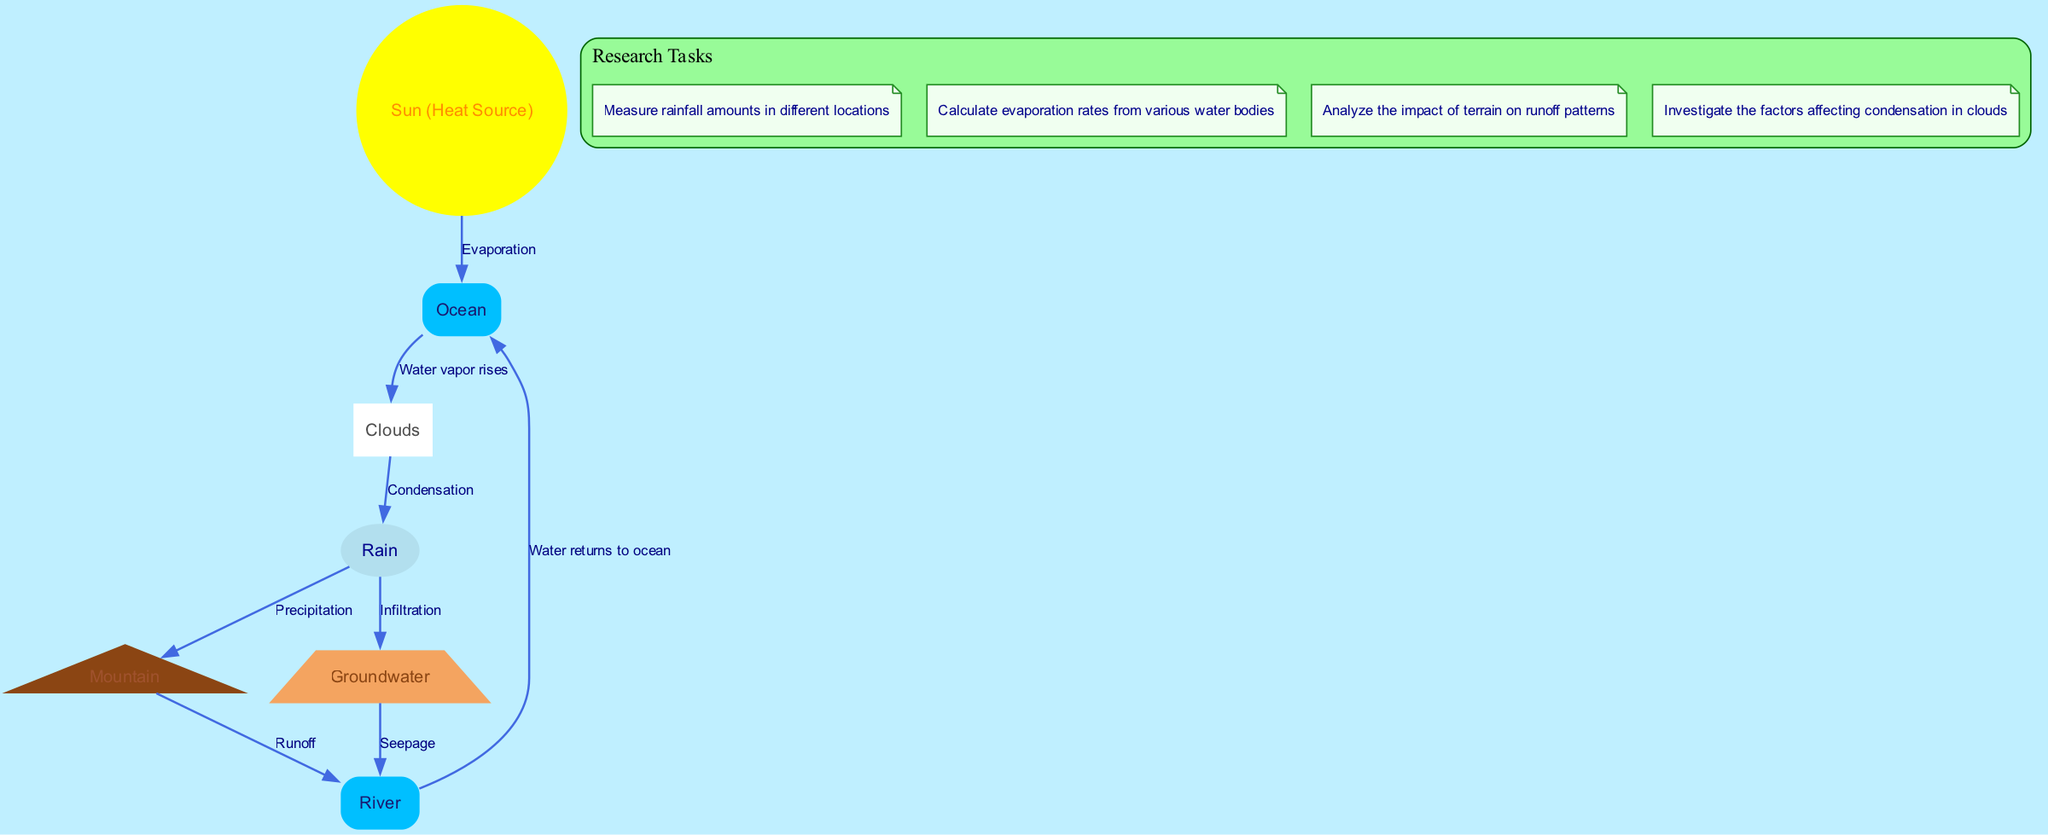What are the key processes illustrated in the water cycle diagram? The diagram shows four key processes: evaporation, condensation, precipitation, and runoff. These processes are interconnected and represent how water moves through different stages in the cycle.
Answer: Evaporation, condensation, precipitation, runoff How many nodes are present in the diagram? The nodes in the diagram include the Sun, Ocean, Clouds, Rain, Mountain, River, and Groundwater. Counting these, we find there are a total of 7 nodes in the diagram.
Answer: 7 What comes after condensation in the water cycle? From the diagram, after condensation occurs in the clouds, the next step illustrated is precipitation, where rain falls from the clouds.
Answer: Precipitation Which node represents the initial source of water vapor? In the diagram, the Sun is indicated as the heating source that initiates the process of evaporation from the Ocean, which produces water vapor.
Answer: Sun What is the relationship between rain and groundwater in the diagram? The diagram shows that rain leads to infiltration, which allows water to seep into the ground, becoming groundwater. This is illustrated by an arrow from rain pointing to groundwater.
Answer: Infiltration How do rivers return water to the ocean in the cycle? The diagram depicts a flow from the River to the Ocean labeled "Water returns to ocean," indicating how rivers play a critical role in returning water back to larger bodies of water after precipitation.
Answer: Water returns to ocean What happens to water after it precipitates on the mountain? After precipitation occurs on the Mountain, the diagram indicates that water undergoes runoff, flowing downwards to the River.
Answer: Runoff What is the significance of the Sun in this cycle? The Sun serves as the heat source that drives evaporation from the Ocean, thus initiating the entire water cycle process by converting liquid water into vapor.
Answer: Heat Source How does groundwater connect back to the river? According to the diagram, groundwater seeps into the River as illustrated by the arrow pointing from groundwater to river, demonstrating the interconnection between these two elements of the water cycle.
Answer: Seepage What process is represented by the arrow from ocean to clouds? The arrow labeled "Water vapor rises" signifies that as water evaporates from the ocean due to heat from the Sun, it rises and forms clouds, showing the transition from liquid to vapor.
Answer: Water vapor rises 